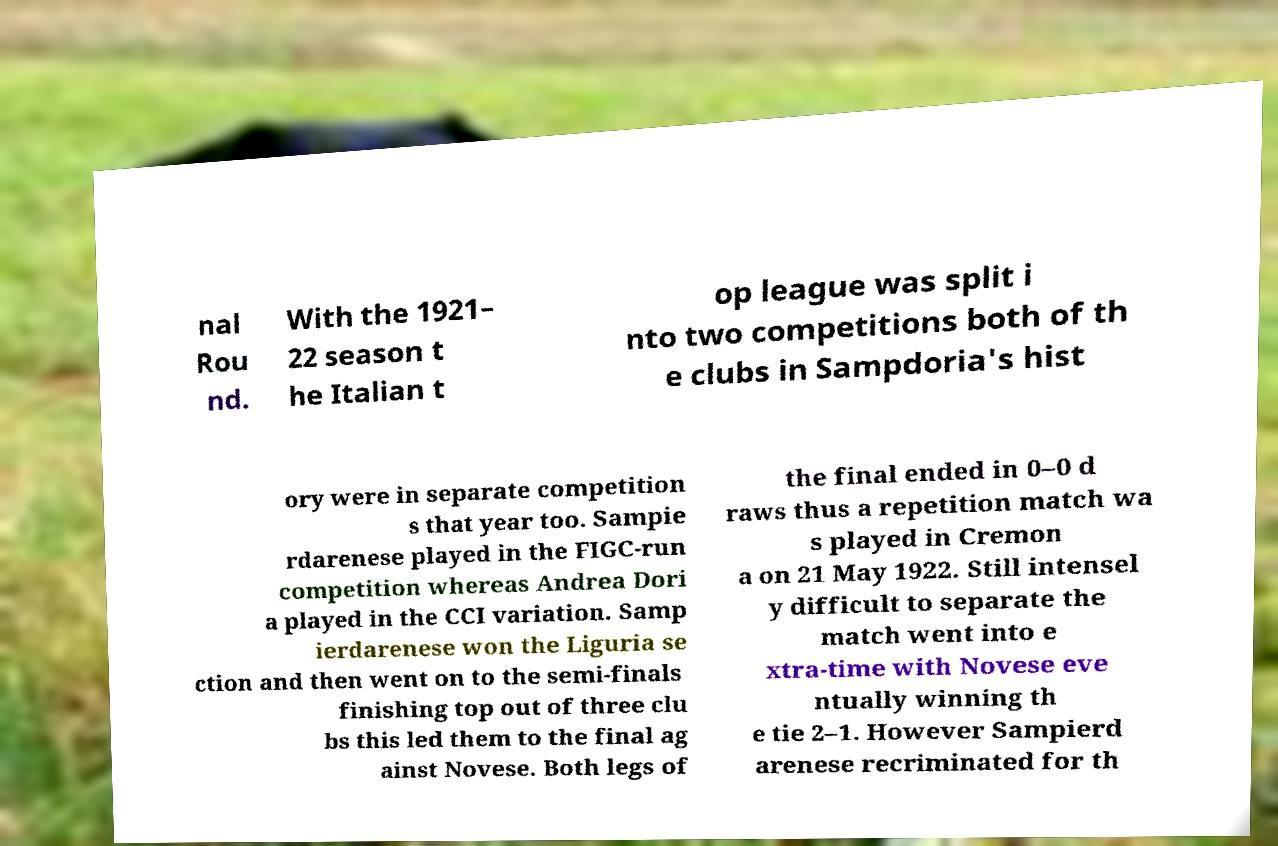Can you read and provide the text displayed in the image?This photo seems to have some interesting text. Can you extract and type it out for me? nal Rou nd. With the 1921– 22 season t he Italian t op league was split i nto two competitions both of th e clubs in Sampdoria's hist ory were in separate competition s that year too. Sampie rdarenese played in the FIGC-run competition whereas Andrea Dori a played in the CCI variation. Samp ierdarenese won the Liguria se ction and then went on to the semi-finals finishing top out of three clu bs this led them to the final ag ainst Novese. Both legs of the final ended in 0–0 d raws thus a repetition match wa s played in Cremon a on 21 May 1922. Still intensel y difficult to separate the match went into e xtra-time with Novese eve ntually winning th e tie 2–1. However Sampierd arenese recriminated for th 